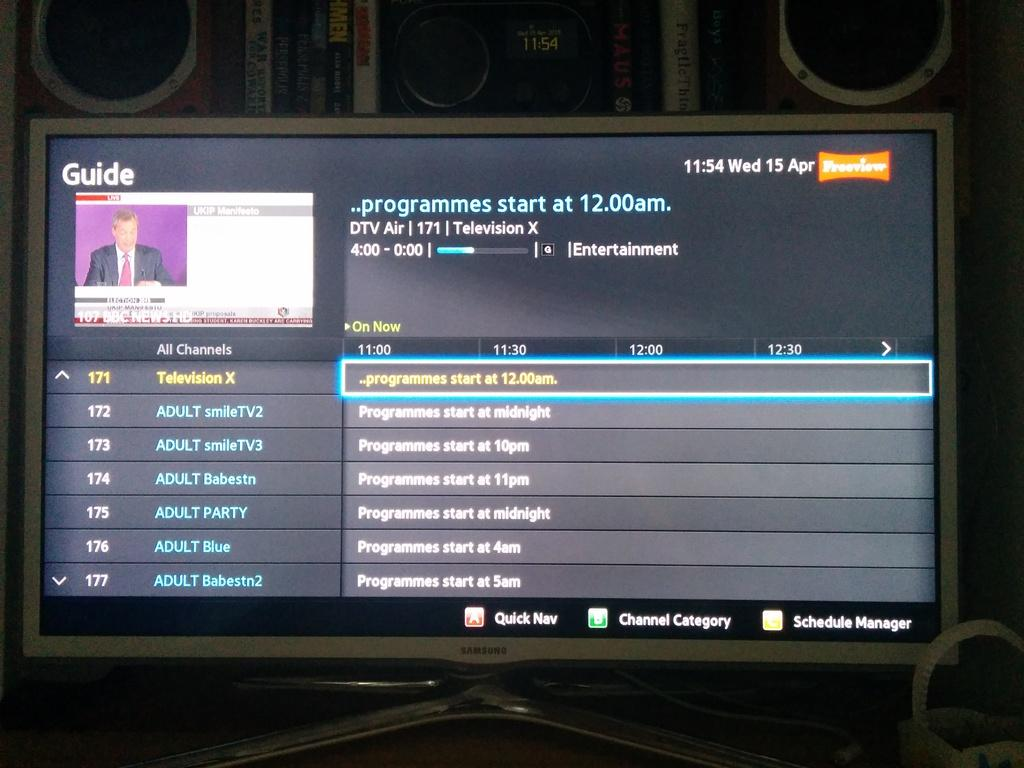What is the main electronic device visible in the image? There is a monitor in the image. What can be seen in the background of the image? There are boxes in the background of the image. Can you tell me how many flights are scheduled to depart from the library in the image? There is no reference to flights or a library in the image, so it's not possible to answer that question. 